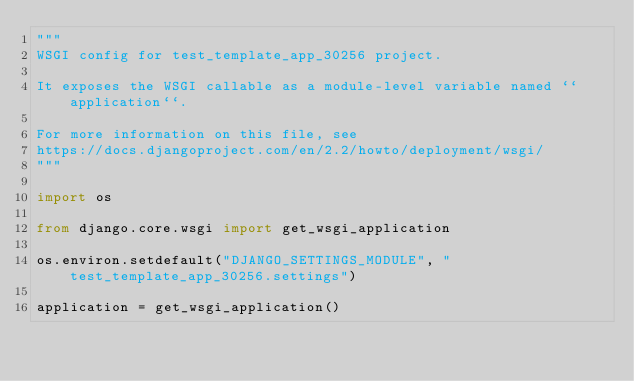<code> <loc_0><loc_0><loc_500><loc_500><_Python_>"""
WSGI config for test_template_app_30256 project.

It exposes the WSGI callable as a module-level variable named ``application``.

For more information on this file, see
https://docs.djangoproject.com/en/2.2/howto/deployment/wsgi/
"""

import os

from django.core.wsgi import get_wsgi_application

os.environ.setdefault("DJANGO_SETTINGS_MODULE", "test_template_app_30256.settings")

application = get_wsgi_application()
</code> 